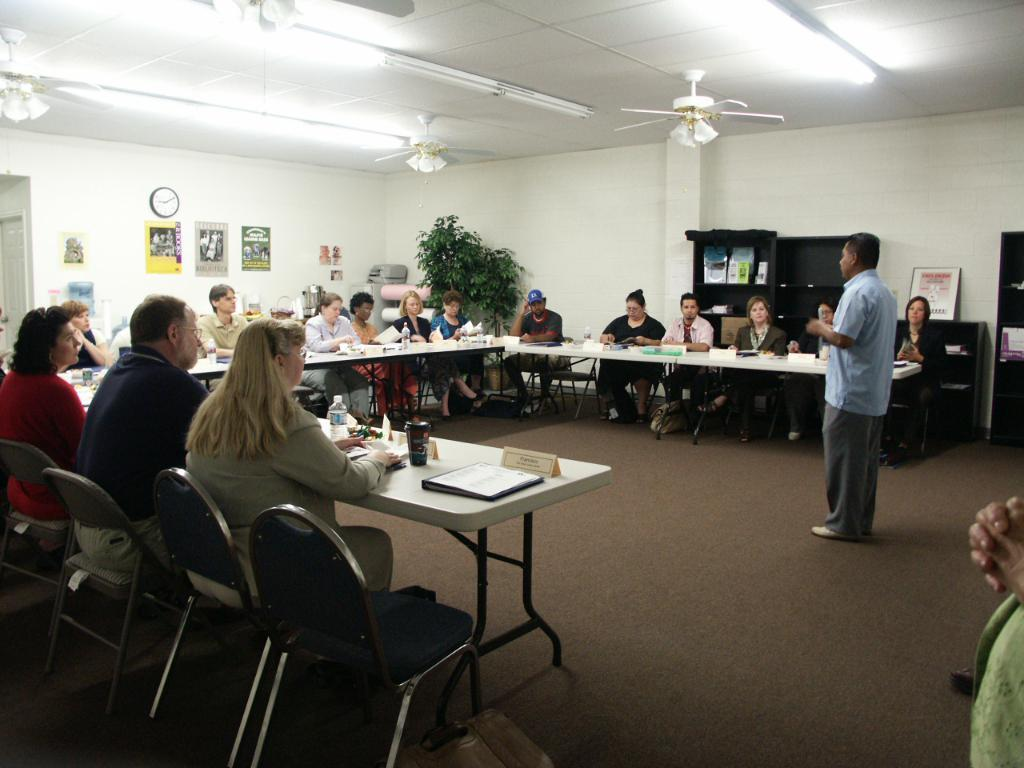How many people are present in the image? There are multiple people in the image. What is the position of the man in the image? A man is standing in the image. What are the other people doing in the image? Other people are sitting on chairs. What objects can be seen on the tables in the image? There are bottles and cups on the tables. Can you see any regrets expressed by the people in the image? There is no indication of regret in the image; it only shows people standing or sitting and objects on tables. 